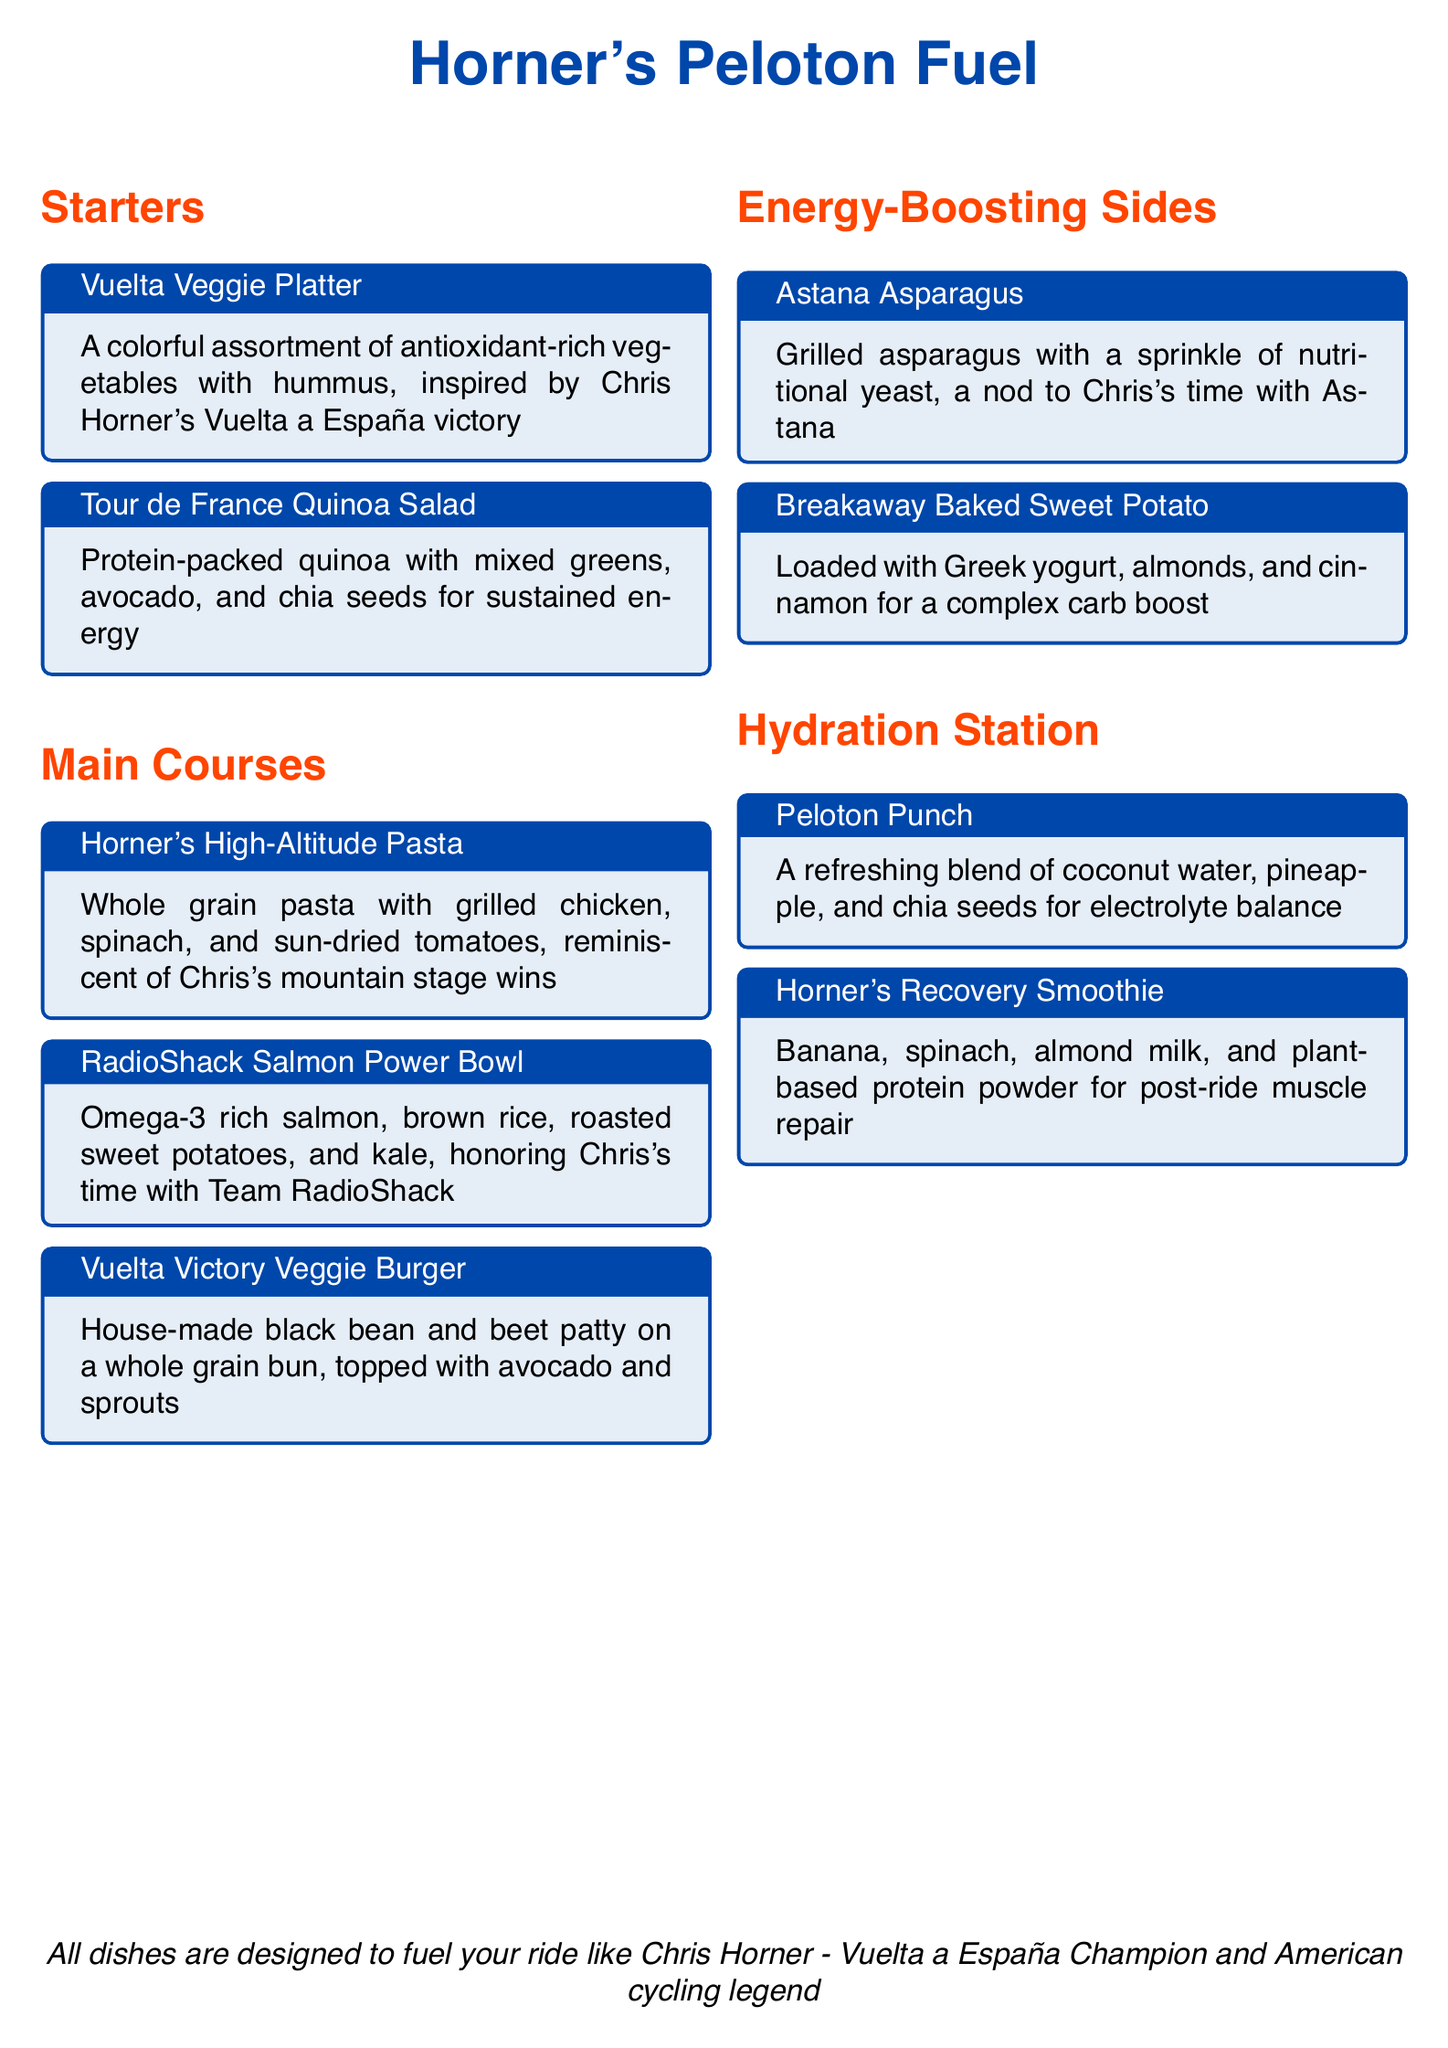What is the name of the restaurant? The restaurant name is prominently displayed at the top of the menu.
Answer: Horner's Peloton Fuel Which dish is inspired by the Vuelta a España? This dish is specifically labeled and highlighted in the starters section.
Answer: Vuelta Veggie Platter What type of fish is included in the RadioShack Salmon Power Bowl? The specific type of fish mentioned in the dish title provides this information.
Answer: Salmon What are the primary ingredients in Horner's Recovery Smoothie? The listed ingredients provide clear details about this menu item, requiring recall.
Answer: Banana, spinach, almond milk, plant-based protein powder Which starter dish features hummus? The description of this starter clearly mentions hummus as an ingredient.
Answer: Vuelta Veggie Platter What type of pasta is featured in the main courses? The title of the dish in the menu indicates the type of pasta used.
Answer: Whole grain pasta What ingredient is used in the Breakaway Baked Sweet Potato? The dish description lists this essential component.
Answer: Greek yogurt How are the Astana Asparagus prepared? The preparation method is specified in the dish description.
Answer: Grilled What is the color theme used in the restaurant menu? The colors are mentioned in the document's color settings, relating to its layout.
Answer: Cycling blue and energy red 